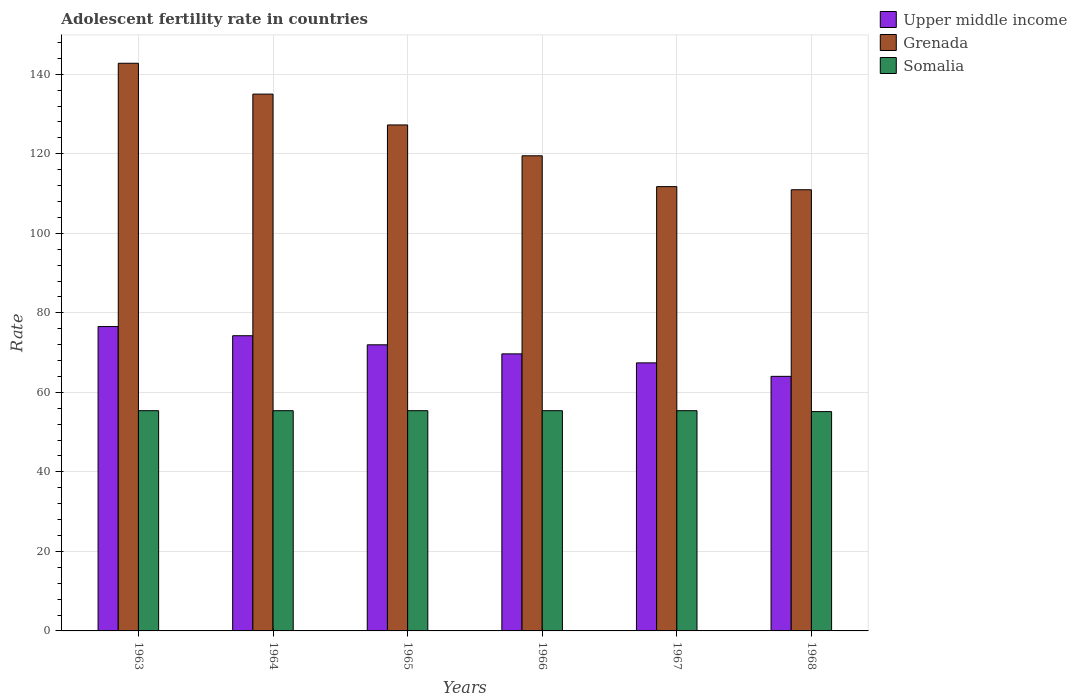How many groups of bars are there?
Give a very brief answer. 6. Are the number of bars per tick equal to the number of legend labels?
Offer a terse response. Yes. How many bars are there on the 5th tick from the right?
Provide a short and direct response. 3. What is the label of the 2nd group of bars from the left?
Your response must be concise. 1964. What is the adolescent fertility rate in Somalia in 1967?
Keep it short and to the point. 55.39. Across all years, what is the maximum adolescent fertility rate in Grenada?
Provide a succinct answer. 142.77. Across all years, what is the minimum adolescent fertility rate in Grenada?
Give a very brief answer. 110.96. In which year was the adolescent fertility rate in Somalia maximum?
Offer a terse response. 1963. In which year was the adolescent fertility rate in Somalia minimum?
Ensure brevity in your answer.  1968. What is the total adolescent fertility rate in Upper middle income in the graph?
Offer a terse response. 423.88. What is the difference between the adolescent fertility rate in Upper middle income in 1965 and that in 1966?
Make the answer very short. 2.28. What is the difference between the adolescent fertility rate in Upper middle income in 1965 and the adolescent fertility rate in Grenada in 1964?
Offer a very short reply. -63.05. What is the average adolescent fertility rate in Grenada per year?
Your answer should be very brief. 124.54. In the year 1968, what is the difference between the adolescent fertility rate in Grenada and adolescent fertility rate in Upper middle income?
Provide a short and direct response. 46.93. In how many years, is the adolescent fertility rate in Upper middle income greater than 64?
Provide a succinct answer. 6. What is the ratio of the adolescent fertility rate in Upper middle income in 1963 to that in 1966?
Provide a short and direct response. 1.1. Is the difference between the adolescent fertility rate in Grenada in 1965 and 1968 greater than the difference between the adolescent fertility rate in Upper middle income in 1965 and 1968?
Make the answer very short. Yes. What is the difference between the highest and the second highest adolescent fertility rate in Somalia?
Ensure brevity in your answer.  0. What is the difference between the highest and the lowest adolescent fertility rate in Somalia?
Give a very brief answer. 0.23. In how many years, is the adolescent fertility rate in Somalia greater than the average adolescent fertility rate in Somalia taken over all years?
Make the answer very short. 5. What does the 2nd bar from the left in 1963 represents?
Your answer should be compact. Grenada. What does the 2nd bar from the right in 1967 represents?
Provide a short and direct response. Grenada. Are the values on the major ticks of Y-axis written in scientific E-notation?
Offer a terse response. No. How are the legend labels stacked?
Your answer should be compact. Vertical. What is the title of the graph?
Provide a succinct answer. Adolescent fertility rate in countries. Does "Equatorial Guinea" appear as one of the legend labels in the graph?
Give a very brief answer. No. What is the label or title of the X-axis?
Offer a terse response. Years. What is the label or title of the Y-axis?
Offer a terse response. Rate. What is the Rate of Upper middle income in 1963?
Offer a very short reply. 76.55. What is the Rate of Grenada in 1963?
Keep it short and to the point. 142.77. What is the Rate of Somalia in 1963?
Provide a succinct answer. 55.39. What is the Rate in Upper middle income in 1964?
Offer a very short reply. 74.24. What is the Rate of Grenada in 1964?
Ensure brevity in your answer.  135.01. What is the Rate of Somalia in 1964?
Your response must be concise. 55.39. What is the Rate in Upper middle income in 1965?
Offer a very short reply. 71.96. What is the Rate of Grenada in 1965?
Give a very brief answer. 127.26. What is the Rate in Somalia in 1965?
Make the answer very short. 55.39. What is the Rate of Upper middle income in 1966?
Ensure brevity in your answer.  69.68. What is the Rate in Grenada in 1966?
Provide a short and direct response. 119.5. What is the Rate of Somalia in 1966?
Your answer should be compact. 55.39. What is the Rate of Upper middle income in 1967?
Make the answer very short. 67.42. What is the Rate of Grenada in 1967?
Ensure brevity in your answer.  111.74. What is the Rate of Somalia in 1967?
Your answer should be very brief. 55.39. What is the Rate in Upper middle income in 1968?
Keep it short and to the point. 64.03. What is the Rate in Grenada in 1968?
Your response must be concise. 110.96. What is the Rate of Somalia in 1968?
Offer a very short reply. 55.16. Across all years, what is the maximum Rate of Upper middle income?
Make the answer very short. 76.55. Across all years, what is the maximum Rate in Grenada?
Ensure brevity in your answer.  142.77. Across all years, what is the maximum Rate of Somalia?
Keep it short and to the point. 55.39. Across all years, what is the minimum Rate in Upper middle income?
Offer a very short reply. 64.03. Across all years, what is the minimum Rate in Grenada?
Offer a very short reply. 110.96. Across all years, what is the minimum Rate of Somalia?
Give a very brief answer. 55.16. What is the total Rate in Upper middle income in the graph?
Give a very brief answer. 423.88. What is the total Rate of Grenada in the graph?
Make the answer very short. 747.25. What is the total Rate in Somalia in the graph?
Your response must be concise. 332.1. What is the difference between the Rate of Upper middle income in 1963 and that in 1964?
Give a very brief answer. 2.31. What is the difference between the Rate in Grenada in 1963 and that in 1964?
Your answer should be compact. 7.76. What is the difference between the Rate of Somalia in 1963 and that in 1964?
Give a very brief answer. 0. What is the difference between the Rate in Upper middle income in 1963 and that in 1965?
Provide a succinct answer. 4.59. What is the difference between the Rate of Grenada in 1963 and that in 1965?
Give a very brief answer. 15.51. What is the difference between the Rate of Upper middle income in 1963 and that in 1966?
Provide a short and direct response. 6.87. What is the difference between the Rate of Grenada in 1963 and that in 1966?
Your response must be concise. 23.27. What is the difference between the Rate in Somalia in 1963 and that in 1966?
Make the answer very short. 0. What is the difference between the Rate of Upper middle income in 1963 and that in 1967?
Your answer should be compact. 9.13. What is the difference between the Rate in Grenada in 1963 and that in 1967?
Give a very brief answer. 31.03. What is the difference between the Rate in Somalia in 1963 and that in 1967?
Your answer should be very brief. 0. What is the difference between the Rate of Upper middle income in 1963 and that in 1968?
Provide a succinct answer. 12.52. What is the difference between the Rate of Grenada in 1963 and that in 1968?
Give a very brief answer. 31.81. What is the difference between the Rate of Somalia in 1963 and that in 1968?
Your answer should be very brief. 0.23. What is the difference between the Rate in Upper middle income in 1964 and that in 1965?
Your response must be concise. 2.28. What is the difference between the Rate of Grenada in 1964 and that in 1965?
Provide a short and direct response. 7.76. What is the difference between the Rate in Upper middle income in 1964 and that in 1966?
Your answer should be very brief. 4.56. What is the difference between the Rate of Grenada in 1964 and that in 1966?
Keep it short and to the point. 15.51. What is the difference between the Rate in Upper middle income in 1964 and that in 1967?
Offer a terse response. 6.83. What is the difference between the Rate in Grenada in 1964 and that in 1967?
Offer a very short reply. 23.27. What is the difference between the Rate in Somalia in 1964 and that in 1967?
Give a very brief answer. 0. What is the difference between the Rate in Upper middle income in 1964 and that in 1968?
Give a very brief answer. 10.22. What is the difference between the Rate of Grenada in 1964 and that in 1968?
Offer a terse response. 24.05. What is the difference between the Rate in Somalia in 1964 and that in 1968?
Offer a terse response. 0.23. What is the difference between the Rate in Upper middle income in 1965 and that in 1966?
Make the answer very short. 2.28. What is the difference between the Rate in Grenada in 1965 and that in 1966?
Provide a succinct answer. 7.76. What is the difference between the Rate of Upper middle income in 1965 and that in 1967?
Your answer should be compact. 4.54. What is the difference between the Rate in Grenada in 1965 and that in 1967?
Ensure brevity in your answer.  15.51. What is the difference between the Rate of Upper middle income in 1965 and that in 1968?
Your response must be concise. 7.93. What is the difference between the Rate in Grenada in 1965 and that in 1968?
Your answer should be compact. 16.3. What is the difference between the Rate in Somalia in 1965 and that in 1968?
Your answer should be very brief. 0.23. What is the difference between the Rate in Upper middle income in 1966 and that in 1967?
Offer a terse response. 2.27. What is the difference between the Rate of Grenada in 1966 and that in 1967?
Provide a short and direct response. 7.76. What is the difference between the Rate in Upper middle income in 1966 and that in 1968?
Ensure brevity in your answer.  5.66. What is the difference between the Rate in Grenada in 1966 and that in 1968?
Your answer should be very brief. 8.54. What is the difference between the Rate of Somalia in 1966 and that in 1968?
Your response must be concise. 0.23. What is the difference between the Rate of Upper middle income in 1967 and that in 1968?
Offer a very short reply. 3.39. What is the difference between the Rate in Grenada in 1967 and that in 1968?
Give a very brief answer. 0.78. What is the difference between the Rate in Somalia in 1967 and that in 1968?
Ensure brevity in your answer.  0.23. What is the difference between the Rate of Upper middle income in 1963 and the Rate of Grenada in 1964?
Your response must be concise. -58.46. What is the difference between the Rate in Upper middle income in 1963 and the Rate in Somalia in 1964?
Your response must be concise. 21.16. What is the difference between the Rate in Grenada in 1963 and the Rate in Somalia in 1964?
Provide a short and direct response. 87.38. What is the difference between the Rate in Upper middle income in 1963 and the Rate in Grenada in 1965?
Give a very brief answer. -50.71. What is the difference between the Rate in Upper middle income in 1963 and the Rate in Somalia in 1965?
Provide a succinct answer. 21.16. What is the difference between the Rate in Grenada in 1963 and the Rate in Somalia in 1965?
Provide a succinct answer. 87.38. What is the difference between the Rate in Upper middle income in 1963 and the Rate in Grenada in 1966?
Provide a short and direct response. -42.95. What is the difference between the Rate of Upper middle income in 1963 and the Rate of Somalia in 1966?
Provide a short and direct response. 21.16. What is the difference between the Rate in Grenada in 1963 and the Rate in Somalia in 1966?
Give a very brief answer. 87.38. What is the difference between the Rate of Upper middle income in 1963 and the Rate of Grenada in 1967?
Offer a terse response. -35.19. What is the difference between the Rate in Upper middle income in 1963 and the Rate in Somalia in 1967?
Your response must be concise. 21.16. What is the difference between the Rate in Grenada in 1963 and the Rate in Somalia in 1967?
Ensure brevity in your answer.  87.38. What is the difference between the Rate of Upper middle income in 1963 and the Rate of Grenada in 1968?
Make the answer very short. -34.41. What is the difference between the Rate in Upper middle income in 1963 and the Rate in Somalia in 1968?
Provide a succinct answer. 21.39. What is the difference between the Rate of Grenada in 1963 and the Rate of Somalia in 1968?
Provide a short and direct response. 87.61. What is the difference between the Rate of Upper middle income in 1964 and the Rate of Grenada in 1965?
Provide a short and direct response. -53.01. What is the difference between the Rate of Upper middle income in 1964 and the Rate of Somalia in 1965?
Make the answer very short. 18.86. What is the difference between the Rate of Grenada in 1964 and the Rate of Somalia in 1965?
Ensure brevity in your answer.  79.63. What is the difference between the Rate of Upper middle income in 1964 and the Rate of Grenada in 1966?
Your response must be concise. -45.26. What is the difference between the Rate of Upper middle income in 1964 and the Rate of Somalia in 1966?
Your response must be concise. 18.86. What is the difference between the Rate in Grenada in 1964 and the Rate in Somalia in 1966?
Keep it short and to the point. 79.63. What is the difference between the Rate in Upper middle income in 1964 and the Rate in Grenada in 1967?
Your response must be concise. -37.5. What is the difference between the Rate in Upper middle income in 1964 and the Rate in Somalia in 1967?
Your response must be concise. 18.86. What is the difference between the Rate of Grenada in 1964 and the Rate of Somalia in 1967?
Offer a very short reply. 79.63. What is the difference between the Rate of Upper middle income in 1964 and the Rate of Grenada in 1968?
Your response must be concise. -36.72. What is the difference between the Rate in Upper middle income in 1964 and the Rate in Somalia in 1968?
Make the answer very short. 19.08. What is the difference between the Rate of Grenada in 1964 and the Rate of Somalia in 1968?
Provide a succinct answer. 79.85. What is the difference between the Rate of Upper middle income in 1965 and the Rate of Grenada in 1966?
Make the answer very short. -47.54. What is the difference between the Rate of Upper middle income in 1965 and the Rate of Somalia in 1966?
Keep it short and to the point. 16.57. What is the difference between the Rate in Grenada in 1965 and the Rate in Somalia in 1966?
Offer a very short reply. 71.87. What is the difference between the Rate of Upper middle income in 1965 and the Rate of Grenada in 1967?
Provide a short and direct response. -39.78. What is the difference between the Rate in Upper middle income in 1965 and the Rate in Somalia in 1967?
Your answer should be compact. 16.57. What is the difference between the Rate in Grenada in 1965 and the Rate in Somalia in 1967?
Your answer should be very brief. 71.87. What is the difference between the Rate in Upper middle income in 1965 and the Rate in Grenada in 1968?
Your response must be concise. -39. What is the difference between the Rate of Upper middle income in 1965 and the Rate of Somalia in 1968?
Give a very brief answer. 16.8. What is the difference between the Rate of Grenada in 1965 and the Rate of Somalia in 1968?
Ensure brevity in your answer.  72.1. What is the difference between the Rate in Upper middle income in 1966 and the Rate in Grenada in 1967?
Ensure brevity in your answer.  -42.06. What is the difference between the Rate of Upper middle income in 1966 and the Rate of Somalia in 1967?
Keep it short and to the point. 14.29. What is the difference between the Rate of Grenada in 1966 and the Rate of Somalia in 1967?
Provide a succinct answer. 64.11. What is the difference between the Rate in Upper middle income in 1966 and the Rate in Grenada in 1968?
Offer a terse response. -41.28. What is the difference between the Rate in Upper middle income in 1966 and the Rate in Somalia in 1968?
Your response must be concise. 14.52. What is the difference between the Rate in Grenada in 1966 and the Rate in Somalia in 1968?
Your response must be concise. 64.34. What is the difference between the Rate in Upper middle income in 1967 and the Rate in Grenada in 1968?
Offer a terse response. -43.54. What is the difference between the Rate of Upper middle income in 1967 and the Rate of Somalia in 1968?
Offer a very short reply. 12.26. What is the difference between the Rate in Grenada in 1967 and the Rate in Somalia in 1968?
Keep it short and to the point. 56.58. What is the average Rate of Upper middle income per year?
Ensure brevity in your answer.  70.65. What is the average Rate in Grenada per year?
Provide a short and direct response. 124.54. What is the average Rate in Somalia per year?
Make the answer very short. 55.35. In the year 1963, what is the difference between the Rate in Upper middle income and Rate in Grenada?
Ensure brevity in your answer.  -66.22. In the year 1963, what is the difference between the Rate of Upper middle income and Rate of Somalia?
Offer a terse response. 21.16. In the year 1963, what is the difference between the Rate of Grenada and Rate of Somalia?
Make the answer very short. 87.38. In the year 1964, what is the difference between the Rate of Upper middle income and Rate of Grenada?
Ensure brevity in your answer.  -60.77. In the year 1964, what is the difference between the Rate of Upper middle income and Rate of Somalia?
Give a very brief answer. 18.86. In the year 1964, what is the difference between the Rate in Grenada and Rate in Somalia?
Your answer should be very brief. 79.63. In the year 1965, what is the difference between the Rate in Upper middle income and Rate in Grenada?
Ensure brevity in your answer.  -55.3. In the year 1965, what is the difference between the Rate of Upper middle income and Rate of Somalia?
Ensure brevity in your answer.  16.57. In the year 1965, what is the difference between the Rate in Grenada and Rate in Somalia?
Offer a very short reply. 71.87. In the year 1966, what is the difference between the Rate of Upper middle income and Rate of Grenada?
Keep it short and to the point. -49.82. In the year 1966, what is the difference between the Rate of Upper middle income and Rate of Somalia?
Your answer should be very brief. 14.29. In the year 1966, what is the difference between the Rate of Grenada and Rate of Somalia?
Ensure brevity in your answer.  64.11. In the year 1967, what is the difference between the Rate of Upper middle income and Rate of Grenada?
Provide a short and direct response. -44.33. In the year 1967, what is the difference between the Rate of Upper middle income and Rate of Somalia?
Provide a succinct answer. 12.03. In the year 1967, what is the difference between the Rate of Grenada and Rate of Somalia?
Ensure brevity in your answer.  56.35. In the year 1968, what is the difference between the Rate of Upper middle income and Rate of Grenada?
Provide a succinct answer. -46.93. In the year 1968, what is the difference between the Rate in Upper middle income and Rate in Somalia?
Your answer should be very brief. 8.87. In the year 1968, what is the difference between the Rate of Grenada and Rate of Somalia?
Your answer should be very brief. 55.8. What is the ratio of the Rate in Upper middle income in 1963 to that in 1964?
Provide a short and direct response. 1.03. What is the ratio of the Rate in Grenada in 1963 to that in 1964?
Provide a short and direct response. 1.06. What is the ratio of the Rate in Upper middle income in 1963 to that in 1965?
Provide a succinct answer. 1.06. What is the ratio of the Rate of Grenada in 1963 to that in 1965?
Offer a very short reply. 1.12. What is the ratio of the Rate in Upper middle income in 1963 to that in 1966?
Your response must be concise. 1.1. What is the ratio of the Rate of Grenada in 1963 to that in 1966?
Make the answer very short. 1.19. What is the ratio of the Rate in Upper middle income in 1963 to that in 1967?
Provide a succinct answer. 1.14. What is the ratio of the Rate in Grenada in 1963 to that in 1967?
Provide a succinct answer. 1.28. What is the ratio of the Rate in Somalia in 1963 to that in 1967?
Give a very brief answer. 1. What is the ratio of the Rate in Upper middle income in 1963 to that in 1968?
Offer a terse response. 1.2. What is the ratio of the Rate in Grenada in 1963 to that in 1968?
Your response must be concise. 1.29. What is the ratio of the Rate in Somalia in 1963 to that in 1968?
Your response must be concise. 1. What is the ratio of the Rate in Upper middle income in 1964 to that in 1965?
Offer a very short reply. 1.03. What is the ratio of the Rate of Grenada in 1964 to that in 1965?
Provide a succinct answer. 1.06. What is the ratio of the Rate of Somalia in 1964 to that in 1965?
Your response must be concise. 1. What is the ratio of the Rate in Upper middle income in 1964 to that in 1966?
Offer a terse response. 1.07. What is the ratio of the Rate in Grenada in 1964 to that in 1966?
Provide a short and direct response. 1.13. What is the ratio of the Rate of Somalia in 1964 to that in 1966?
Keep it short and to the point. 1. What is the ratio of the Rate in Upper middle income in 1964 to that in 1967?
Ensure brevity in your answer.  1.1. What is the ratio of the Rate in Grenada in 1964 to that in 1967?
Your answer should be very brief. 1.21. What is the ratio of the Rate of Somalia in 1964 to that in 1967?
Your answer should be very brief. 1. What is the ratio of the Rate in Upper middle income in 1964 to that in 1968?
Your answer should be compact. 1.16. What is the ratio of the Rate in Grenada in 1964 to that in 1968?
Your answer should be compact. 1.22. What is the ratio of the Rate in Somalia in 1964 to that in 1968?
Your answer should be compact. 1. What is the ratio of the Rate in Upper middle income in 1965 to that in 1966?
Ensure brevity in your answer.  1.03. What is the ratio of the Rate of Grenada in 1965 to that in 1966?
Your answer should be compact. 1.06. What is the ratio of the Rate in Upper middle income in 1965 to that in 1967?
Keep it short and to the point. 1.07. What is the ratio of the Rate of Grenada in 1965 to that in 1967?
Give a very brief answer. 1.14. What is the ratio of the Rate of Somalia in 1965 to that in 1967?
Provide a short and direct response. 1. What is the ratio of the Rate of Upper middle income in 1965 to that in 1968?
Offer a very short reply. 1.12. What is the ratio of the Rate of Grenada in 1965 to that in 1968?
Give a very brief answer. 1.15. What is the ratio of the Rate of Somalia in 1965 to that in 1968?
Your answer should be very brief. 1. What is the ratio of the Rate in Upper middle income in 1966 to that in 1967?
Your response must be concise. 1.03. What is the ratio of the Rate of Grenada in 1966 to that in 1967?
Give a very brief answer. 1.07. What is the ratio of the Rate in Somalia in 1966 to that in 1967?
Ensure brevity in your answer.  1. What is the ratio of the Rate of Upper middle income in 1966 to that in 1968?
Your answer should be very brief. 1.09. What is the ratio of the Rate in Grenada in 1966 to that in 1968?
Give a very brief answer. 1.08. What is the ratio of the Rate of Upper middle income in 1967 to that in 1968?
Offer a very short reply. 1.05. What is the ratio of the Rate in Grenada in 1967 to that in 1968?
Ensure brevity in your answer.  1.01. What is the ratio of the Rate in Somalia in 1967 to that in 1968?
Provide a succinct answer. 1. What is the difference between the highest and the second highest Rate of Upper middle income?
Provide a short and direct response. 2.31. What is the difference between the highest and the second highest Rate of Grenada?
Your answer should be compact. 7.76. What is the difference between the highest and the lowest Rate of Upper middle income?
Your response must be concise. 12.52. What is the difference between the highest and the lowest Rate of Grenada?
Provide a succinct answer. 31.81. What is the difference between the highest and the lowest Rate in Somalia?
Your response must be concise. 0.23. 